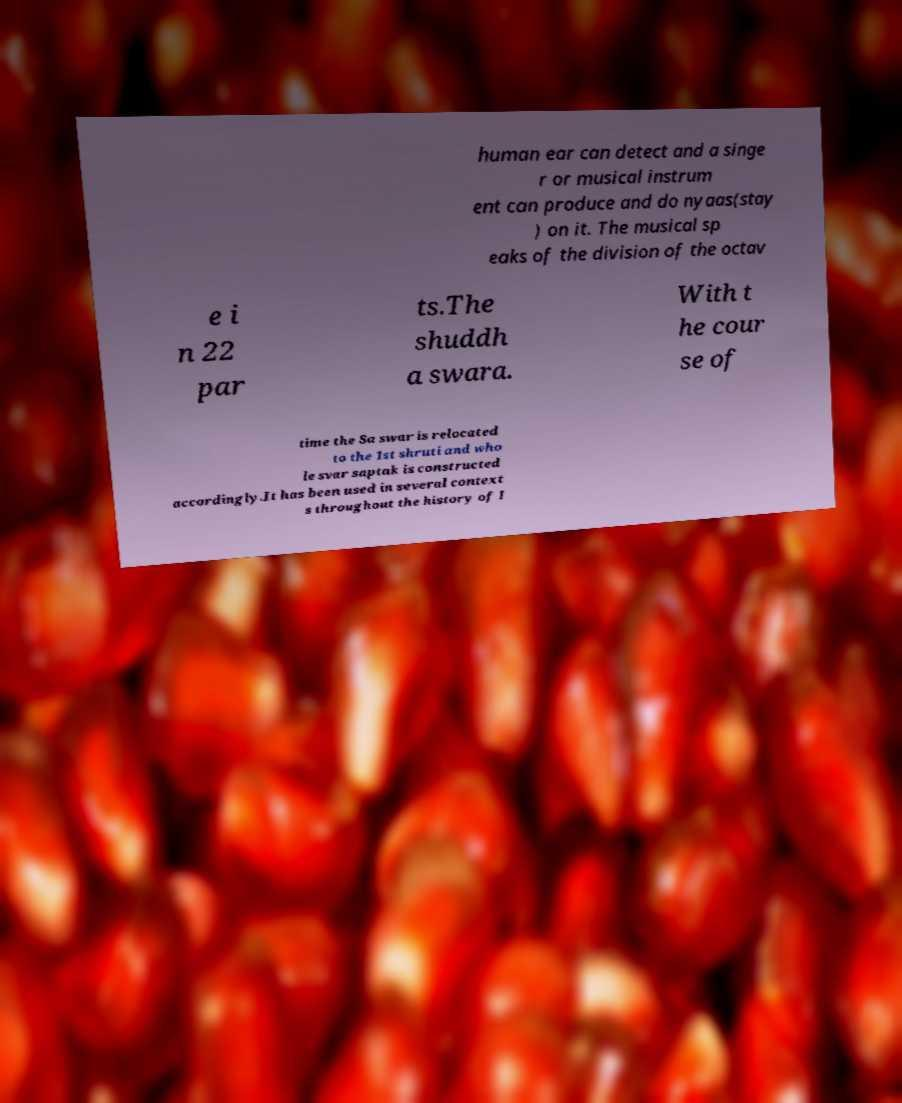There's text embedded in this image that I need extracted. Can you transcribe it verbatim? human ear can detect and a singe r or musical instrum ent can produce and do nyaas(stay ) on it. The musical sp eaks of the division of the octav e i n 22 par ts.The shuddh a swara. With t he cour se of time the Sa swar is relocated to the 1st shruti and who le svar saptak is constructed accordingly.It has been used in several context s throughout the history of I 